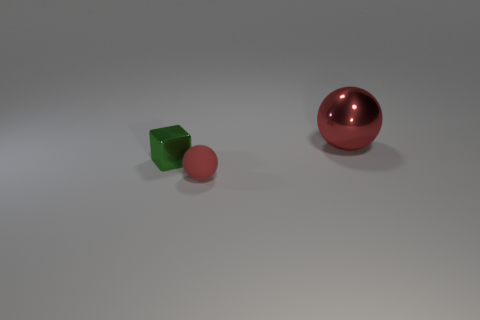What number of other objects are the same shape as the green object? In this image, the green object is a cube. Upon reviewing the shapes of the other objects, there appears to be no other cube present. Therefore, the number of objects that share the same shape as the green cube is zero. 